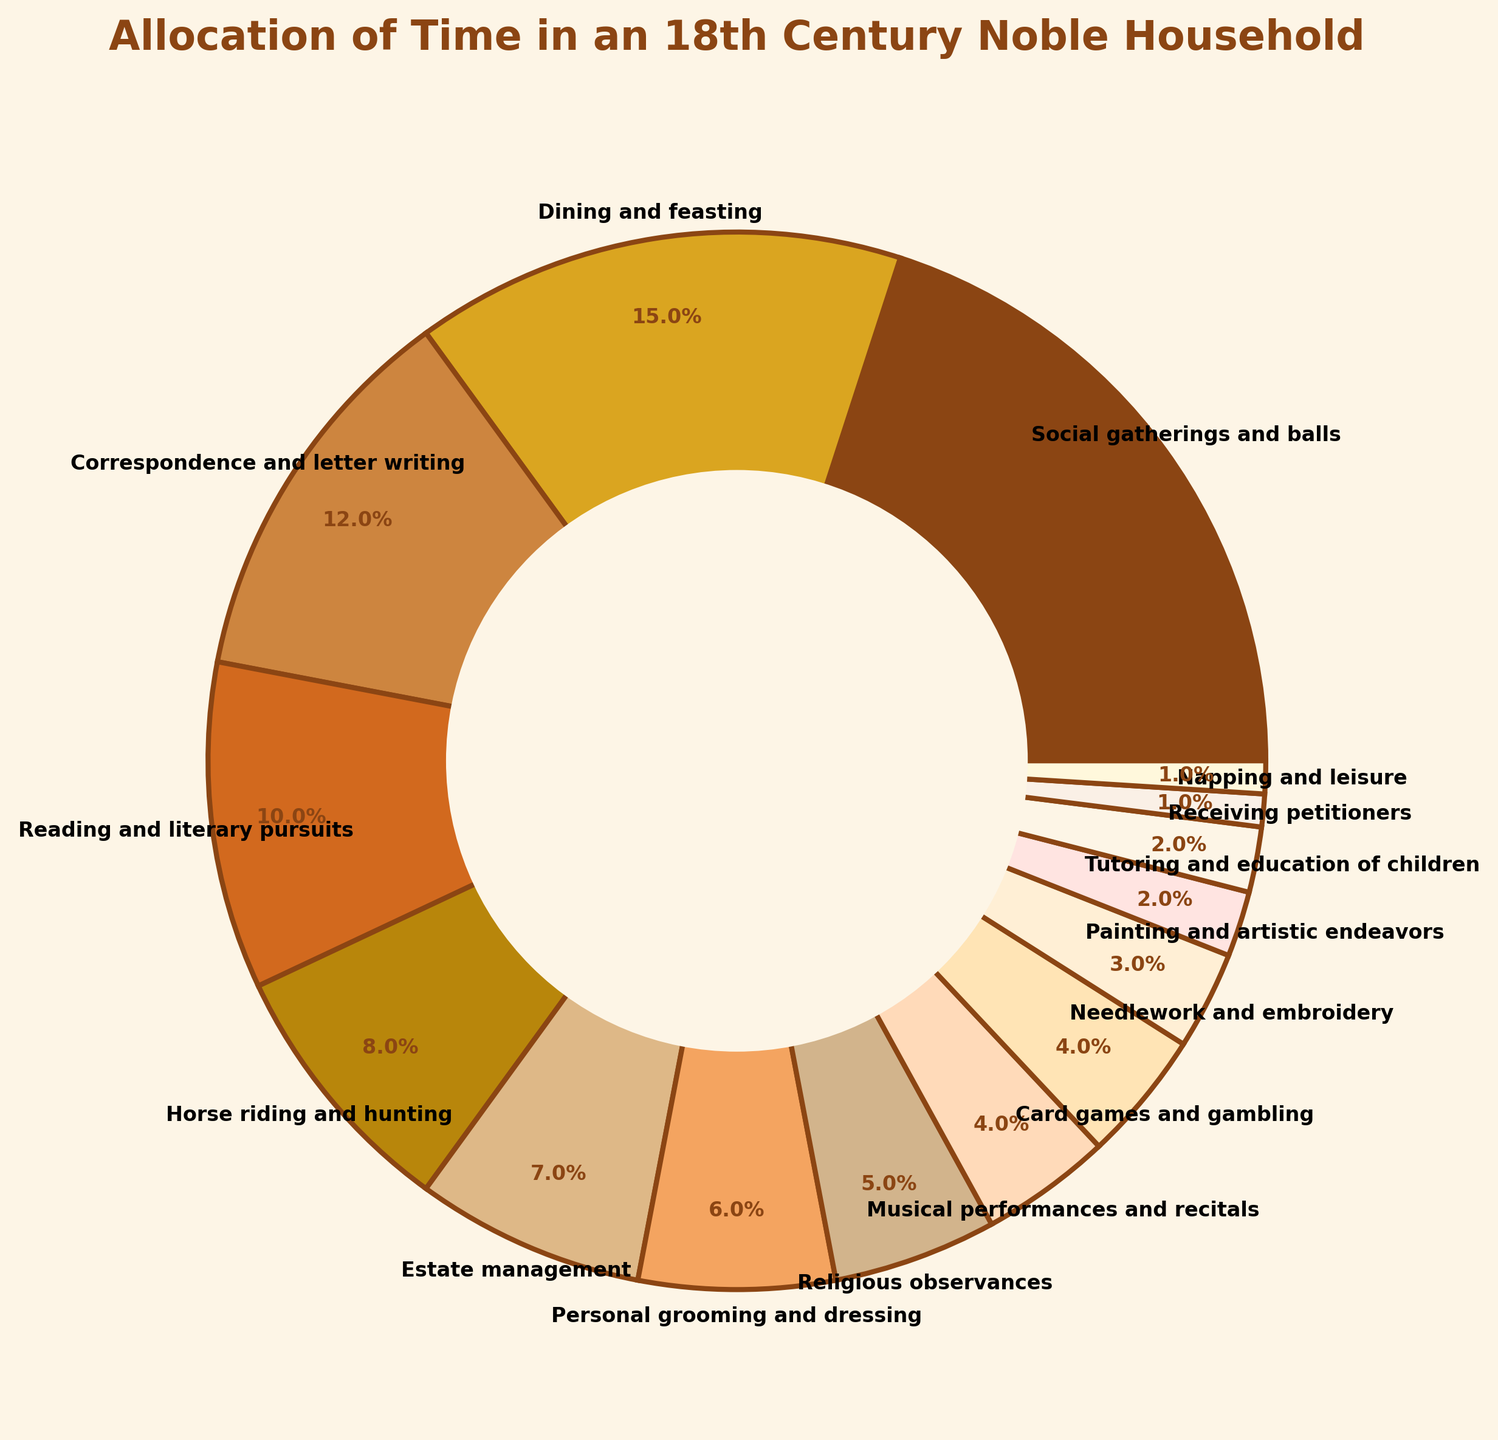Which activity consumes the largest portion of time in the 18th century noble household? The pie chart shows that "Social gatherings and balls" have the largest segment, indicating it consumes the most time among listed activities.
Answer: Social gatherings and balls What is the combined percentage of time spent on "Dining and feasting" and "Reading and literary pursuits"? The chart indicates "Dining and feasting" is 15% and "Reading and literary pursuits" is 10%. Summing these two gives 15% + 10% = 25%.
Answer: 25% Is more time allocated to "Horse riding and hunting" or "Personal grooming and dressing"? Comparing the pie chart segments, "Horse riding and hunting" is 8% and "Personal grooming and dressing" is 6%. Therefore, more time is allocated to "Horse riding and hunting".
Answer: Horse riding and hunting Which activity has the smallest time allocation? The smallest segment in the pie chart represents "Receiving petitioners" and "Napping and leisure", each with 1%.
Answer: Receiving petitioners and Napping and leisure How much more time is spent on "Correspondence and letter writing" compared to "Musical performances and recitals"? "Correspondence and letter writing" has 12% and "Musical performances and recitals" has 4% according to the pie chart. The difference is 12% - 4% = 8%.
Answer: 8% What percentage of time is allocated to activities directly related to estate management, i.e., "Estate management" and "Receiving petitioners"? The chart shows "Estate management" is 7% and "Receiving petitioners" is 1%. Summing these gives 7% + 1% = 8%.
Answer: 8% How does the time spent on "Religious observances" compare to the time spent on "Card games and gambling"? The pie chart segments indicate "Religious observances" is 5% and "Card games and gambling" is 4%. Hence, more time is spent on "Religious observances".
Answer: Religious observances What is the total percentage of time spent on leisure activities, assuming they include "Napping and leisure", "Card games and gambling", and "Musical performances and recitals"? Adding the pie chart segments for these activities: "Napping and leisure" (1%), "Card games and gambling" (4%), and "Musical performances and recitals" (4%), results in 1% + 4% + 4% = 9%.
Answer: 9% 